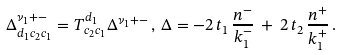<formula> <loc_0><loc_0><loc_500><loc_500>\Delta _ { d _ { 1 } c _ { 2 } c _ { 1 } } ^ { \nu _ { 1 } + - } = T _ { c _ { 2 } c _ { 1 } } ^ { d _ { 1 } } \Delta ^ { \nu _ { 1 } + - } \, , \, \Delta = - 2 \, t _ { 1 } \, \frac { n ^ { - } } { k _ { 1 } ^ { - } } \, + \, 2 \, t _ { 2 } \, \frac { n ^ { + } } { k _ { 1 } ^ { + } } \, .</formula> 